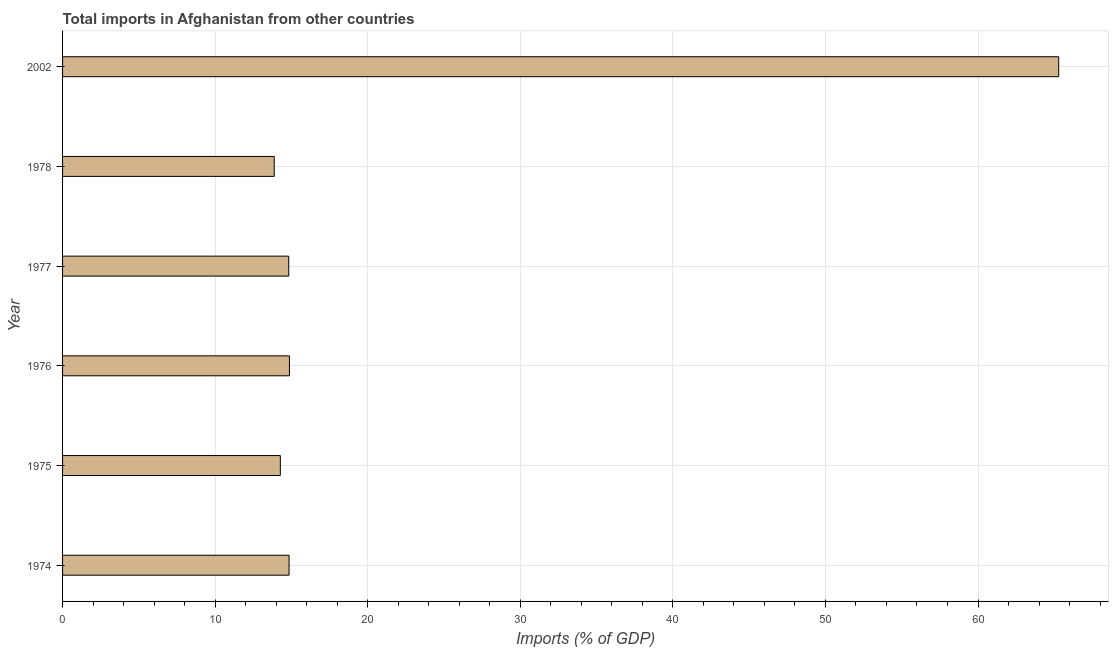Does the graph contain any zero values?
Your answer should be very brief. No. What is the title of the graph?
Your response must be concise. Total imports in Afghanistan from other countries. What is the label or title of the X-axis?
Provide a short and direct response. Imports (% of GDP). What is the total imports in 2002?
Your response must be concise. 65.29. Across all years, what is the maximum total imports?
Provide a short and direct response. 65.29. Across all years, what is the minimum total imports?
Keep it short and to the point. 13.87. In which year was the total imports minimum?
Offer a very short reply. 1978. What is the sum of the total imports?
Provide a succinct answer. 137.97. What is the difference between the total imports in 1974 and 1978?
Keep it short and to the point. 0.97. What is the average total imports per year?
Provide a short and direct response. 23. What is the median total imports?
Your answer should be compact. 14.83. In how many years, is the total imports greater than 48 %?
Your answer should be very brief. 1. Do a majority of the years between 2002 and 1976 (inclusive) have total imports greater than 60 %?
Ensure brevity in your answer.  Yes. What is the ratio of the total imports in 1978 to that in 2002?
Your answer should be compact. 0.21. Is the total imports in 1975 less than that in 1977?
Make the answer very short. Yes. What is the difference between the highest and the second highest total imports?
Give a very brief answer. 50.42. What is the difference between the highest and the lowest total imports?
Provide a short and direct response. 51.42. Are all the bars in the graph horizontal?
Make the answer very short. Yes. What is the Imports (% of GDP) in 1974?
Your answer should be compact. 14.85. What is the Imports (% of GDP) of 1975?
Keep it short and to the point. 14.27. What is the Imports (% of GDP) of 1976?
Give a very brief answer. 14.87. What is the Imports (% of GDP) of 1977?
Your answer should be compact. 14.82. What is the Imports (% of GDP) of 1978?
Provide a short and direct response. 13.87. What is the Imports (% of GDP) in 2002?
Your answer should be compact. 65.29. What is the difference between the Imports (% of GDP) in 1974 and 1975?
Make the answer very short. 0.57. What is the difference between the Imports (% of GDP) in 1974 and 1976?
Keep it short and to the point. -0.02. What is the difference between the Imports (% of GDP) in 1974 and 1977?
Give a very brief answer. 0.02. What is the difference between the Imports (% of GDP) in 1974 and 1978?
Offer a very short reply. 0.97. What is the difference between the Imports (% of GDP) in 1974 and 2002?
Make the answer very short. -50.44. What is the difference between the Imports (% of GDP) in 1975 and 1976?
Ensure brevity in your answer.  -0.6. What is the difference between the Imports (% of GDP) in 1975 and 1977?
Make the answer very short. -0.55. What is the difference between the Imports (% of GDP) in 1975 and 1978?
Give a very brief answer. 0.4. What is the difference between the Imports (% of GDP) in 1975 and 2002?
Your answer should be very brief. -51.02. What is the difference between the Imports (% of GDP) in 1976 and 1977?
Provide a short and direct response. 0.05. What is the difference between the Imports (% of GDP) in 1976 and 1978?
Offer a very short reply. 1. What is the difference between the Imports (% of GDP) in 1976 and 2002?
Give a very brief answer. -50.42. What is the difference between the Imports (% of GDP) in 1977 and 1978?
Offer a very short reply. 0.95. What is the difference between the Imports (% of GDP) in 1977 and 2002?
Ensure brevity in your answer.  -50.46. What is the difference between the Imports (% of GDP) in 1978 and 2002?
Offer a very short reply. -51.42. What is the ratio of the Imports (% of GDP) in 1974 to that in 1975?
Your answer should be compact. 1.04. What is the ratio of the Imports (% of GDP) in 1974 to that in 1977?
Give a very brief answer. 1. What is the ratio of the Imports (% of GDP) in 1974 to that in 1978?
Make the answer very short. 1.07. What is the ratio of the Imports (% of GDP) in 1974 to that in 2002?
Offer a terse response. 0.23. What is the ratio of the Imports (% of GDP) in 1975 to that in 2002?
Keep it short and to the point. 0.22. What is the ratio of the Imports (% of GDP) in 1976 to that in 1977?
Provide a short and direct response. 1. What is the ratio of the Imports (% of GDP) in 1976 to that in 1978?
Offer a terse response. 1.07. What is the ratio of the Imports (% of GDP) in 1976 to that in 2002?
Offer a very short reply. 0.23. What is the ratio of the Imports (% of GDP) in 1977 to that in 1978?
Give a very brief answer. 1.07. What is the ratio of the Imports (% of GDP) in 1977 to that in 2002?
Offer a very short reply. 0.23. What is the ratio of the Imports (% of GDP) in 1978 to that in 2002?
Your answer should be very brief. 0.21. 